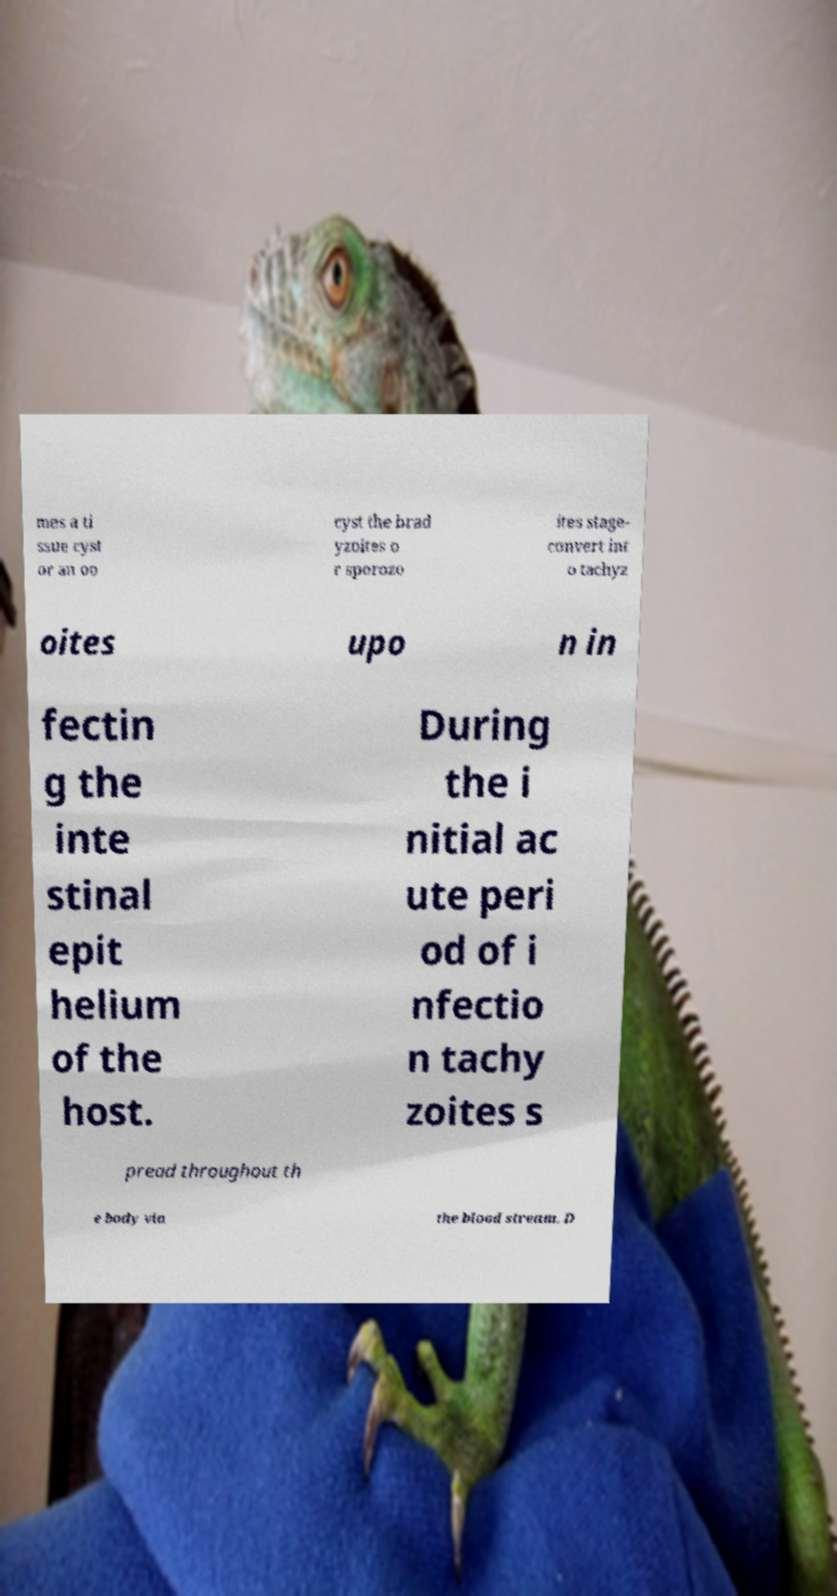I need the written content from this picture converted into text. Can you do that? mes a ti ssue cyst or an oo cyst the brad yzoites o r sporozo ites stage- convert int o tachyz oites upo n in fectin g the inte stinal epit helium of the host. During the i nitial ac ute peri od of i nfectio n tachy zoites s pread throughout th e body via the blood stream. D 